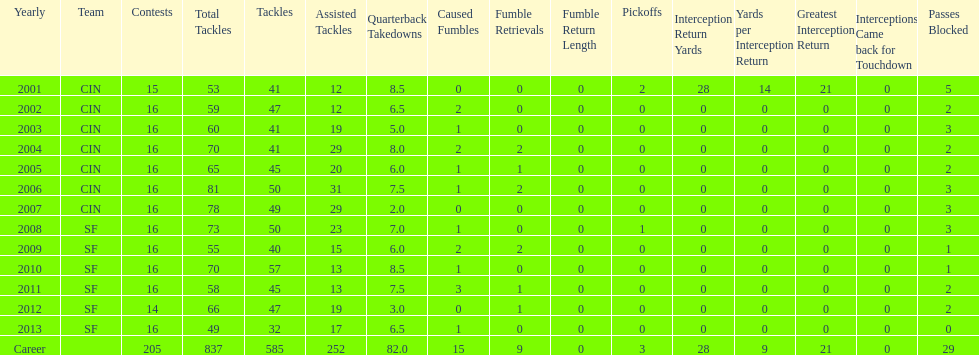Would you mind parsing the complete table? {'header': ['Yearly', 'Team', 'Contests', 'Total Tackles', 'Tackles', 'Assisted Tackles', 'Quarterback Takedowns', 'Caused Fumbles', 'Fumble Retrievals', 'Fumble Return Length', 'Pickoffs', 'Interception Return Yards', 'Yards per Interception Return', 'Greatest Interception Return', 'Interceptions Came back for Touchdown', 'Passes Blocked'], 'rows': [['2001', 'CIN', '15', '53', '41', '12', '8.5', '0', '0', '0', '2', '28', '14', '21', '0', '5'], ['2002', 'CIN', '16', '59', '47', '12', '6.5', '2', '0', '0', '0', '0', '0', '0', '0', '2'], ['2003', 'CIN', '16', '60', '41', '19', '5.0', '1', '0', '0', '0', '0', '0', '0', '0', '3'], ['2004', 'CIN', '16', '70', '41', '29', '8.0', '2', '2', '0', '0', '0', '0', '0', '0', '2'], ['2005', 'CIN', '16', '65', '45', '20', '6.0', '1', '1', '0', '0', '0', '0', '0', '0', '2'], ['2006', 'CIN', '16', '81', '50', '31', '7.5', '1', '2', '0', '0', '0', '0', '0', '0', '3'], ['2007', 'CIN', '16', '78', '49', '29', '2.0', '0', '0', '0', '0', '0', '0', '0', '0', '3'], ['2008', 'SF', '16', '73', '50', '23', '7.0', '1', '0', '0', '1', '0', '0', '0', '0', '3'], ['2009', 'SF', '16', '55', '40', '15', '6.0', '2', '2', '0', '0', '0', '0', '0', '0', '1'], ['2010', 'SF', '16', '70', '57', '13', '8.5', '1', '0', '0', '0', '0', '0', '0', '0', '1'], ['2011', 'SF', '16', '58', '45', '13', '7.5', '3', '1', '0', '0', '0', '0', '0', '0', '2'], ['2012', 'SF', '14', '66', '47', '19', '3.0', '0', '1', '0', '0', '0', '0', '0', '0', '2'], ['2013', 'SF', '16', '49', '32', '17', '6.5', '1', '0', '0', '0', '0', '0', '0', '0', '0'], ['Career', '', '205', '837', '585', '252', '82.0', '15', '9', '0', '3', '28', '9', '21', '0', '29']]} What is the average number of tackles this player has had over his career? 45. 